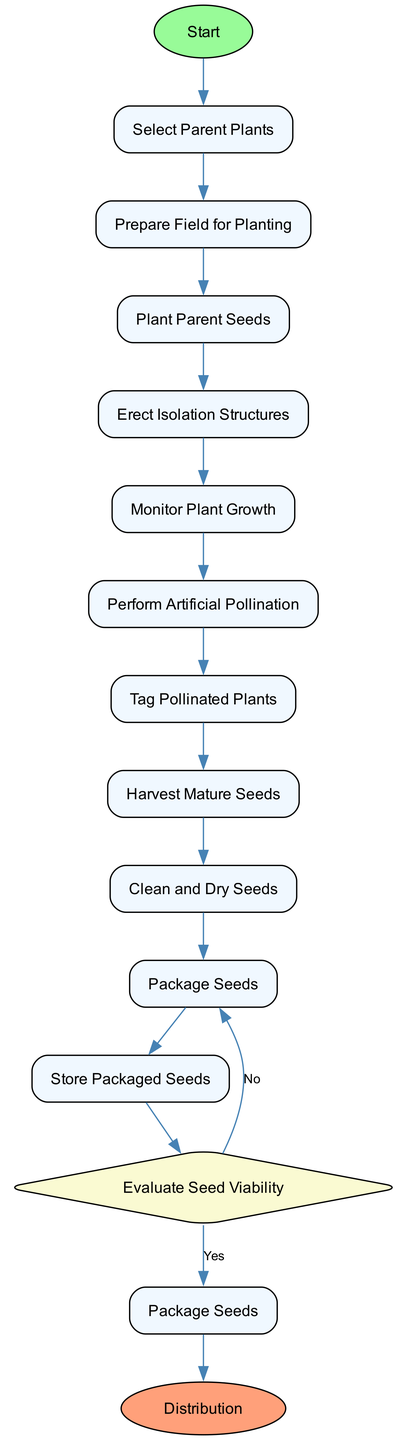What is the first activity in the diagram? The first activity is "Select Parent Plants," as it is the first node after the start node in the sequence of activities.
Answer: Select Parent Plants How many total activities are shown in the diagram? The diagram includes a total of 11 activities listed before the decision node, including the harvesting and cleaning steps.
Answer: 11 What activity follows "Plant Parent Seeds"? The activity that directly follows "Plant Parent Seeds" is "Erect Isolation Structures," as it is linked in the sequential flow of activities within the diagram.
Answer: Erect Isolation Structures What is the purpose of the "Evaluate Seed Viability" decision? The decision "Evaluate Seed Viability" is intended to assess the germination rate of seeds to ensure they are of high quality before they are packaged and distributed.
Answer: Test seed germination rate If the seed viability test is successful, what is the next step? If the seed viability test is passed (Yes branch), the following step is to "Package Seeds," continuing the process to prepare the seeds for distribution.
Answer: Package Seeds Which activity is the last before the distribution of seeds? The last activity before distribution is "Store Packaged Seeds," as it prepares the packaged seeds for storage allowing them to maintain viability until they are distributed.
Answer: Store Packaged Seeds What is the final node in the diagram? The final node displayed in the diagram is labeled "Distribution," which signifies the end of the process where the packaged seeds are sent out to consumers.
Answer: Distribution What activity takes place immediately before "Harvest Mature Seeds"? The activity that occurs immediately before "Harvest Mature Seeds" is "Tag Pollinated Plants," as it is essential to identify and track the plants that have been successfully pollinated.
Answer: Tag Pollinated Plants Which activity deals with preventing pollen contamination? The activity that is specifically aimed at preventing pollen contamination is "Erect Isolation Structures," as this creates barriers to protect the pollination process.
Answer: Erect Isolation Structures 